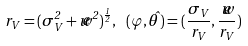<formula> <loc_0><loc_0><loc_500><loc_500>r _ { V } = ( \sigma _ { V } ^ { 2 } + \widetilde { w } ^ { 2 } ) ^ { \frac { 1 } { 2 } } , \ ( \varphi , \hat { \theta } ) = ( \frac { \sigma _ { V } } { r _ { V } } , \frac { \widetilde { w } } { r _ { V } } )</formula> 